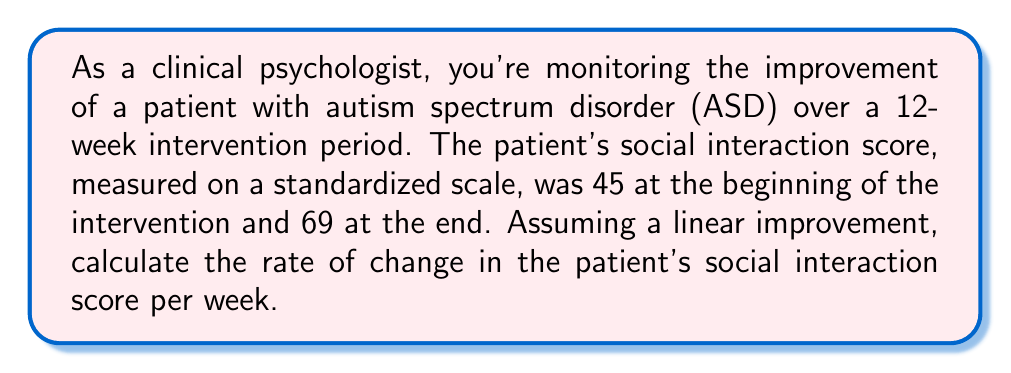Show me your answer to this math problem. To calculate the rate of change, we'll use the linear function formula:

$$ \text{Rate of change} = \frac{\text{Change in y}}{\text{Change in x}} $$

Where:
- y represents the social interaction score
- x represents the time in weeks

Step 1: Determine the change in y (social interaction score)
$$ \Delta y = \text{Final score} - \text{Initial score} = 69 - 45 = 24 $$

Step 2: Determine the change in x (time)
$$ \Delta x = 12 \text{ weeks} $$

Step 3: Apply the rate of change formula
$$ \text{Rate of change} = \frac{\Delta y}{\Delta x} = \frac{24}{12} = 2 $$

Therefore, the rate of change in the patient's social interaction score is 2 points per week.
Answer: $2 \text{ points/week}$ 